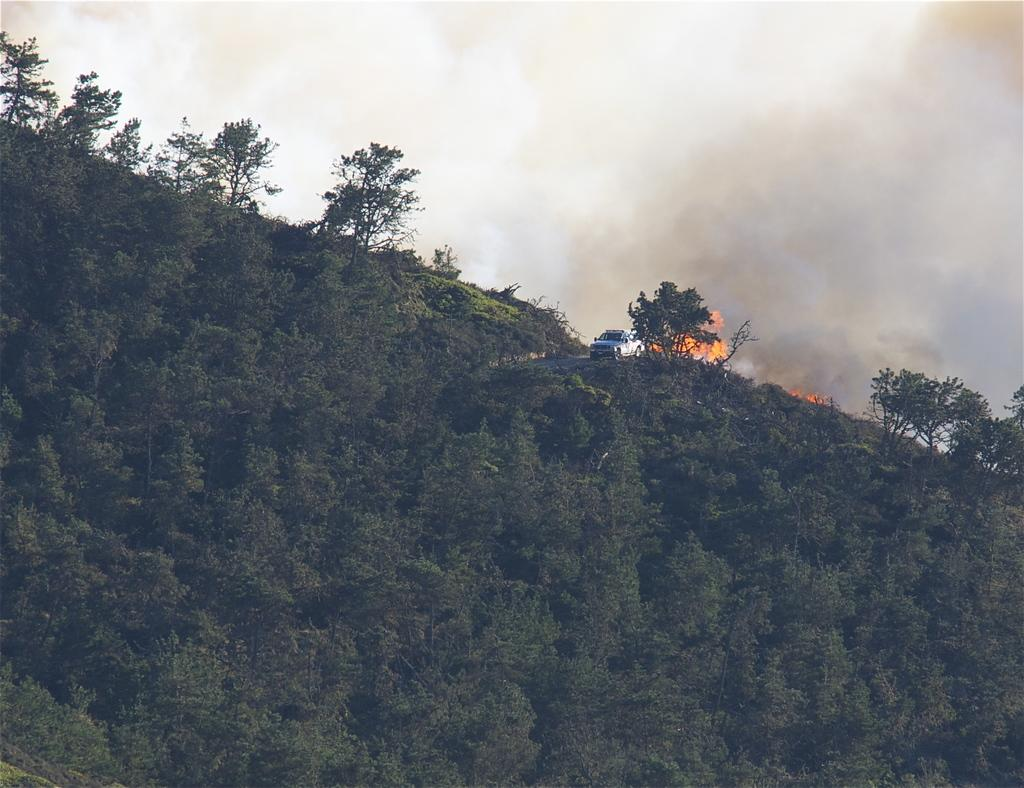What can be seen on the hill in the image? There are trees on a hill in the image. What else is present in the image besides the trees on the hill? There is a vehicle and a fire with smoke in the image. What type of jewel is being used to control the fire in the image? There is no jewel present in the image; the fire is producing smoke on its own. How does the wheel in the image help to extinguish the fire? There is no wheel present in the image that could be used to extinguish the fire. 